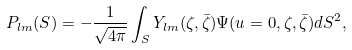<formula> <loc_0><loc_0><loc_500><loc_500>P _ { l m } ( S ) = - \frac { 1 } { \sqrt { 4 \pi } } \int _ { S } Y _ { l m } ( \zeta , \bar { \zeta } ) \Psi ( u = 0 , \zeta , \bar { \zeta } ) d S ^ { 2 } ,</formula> 